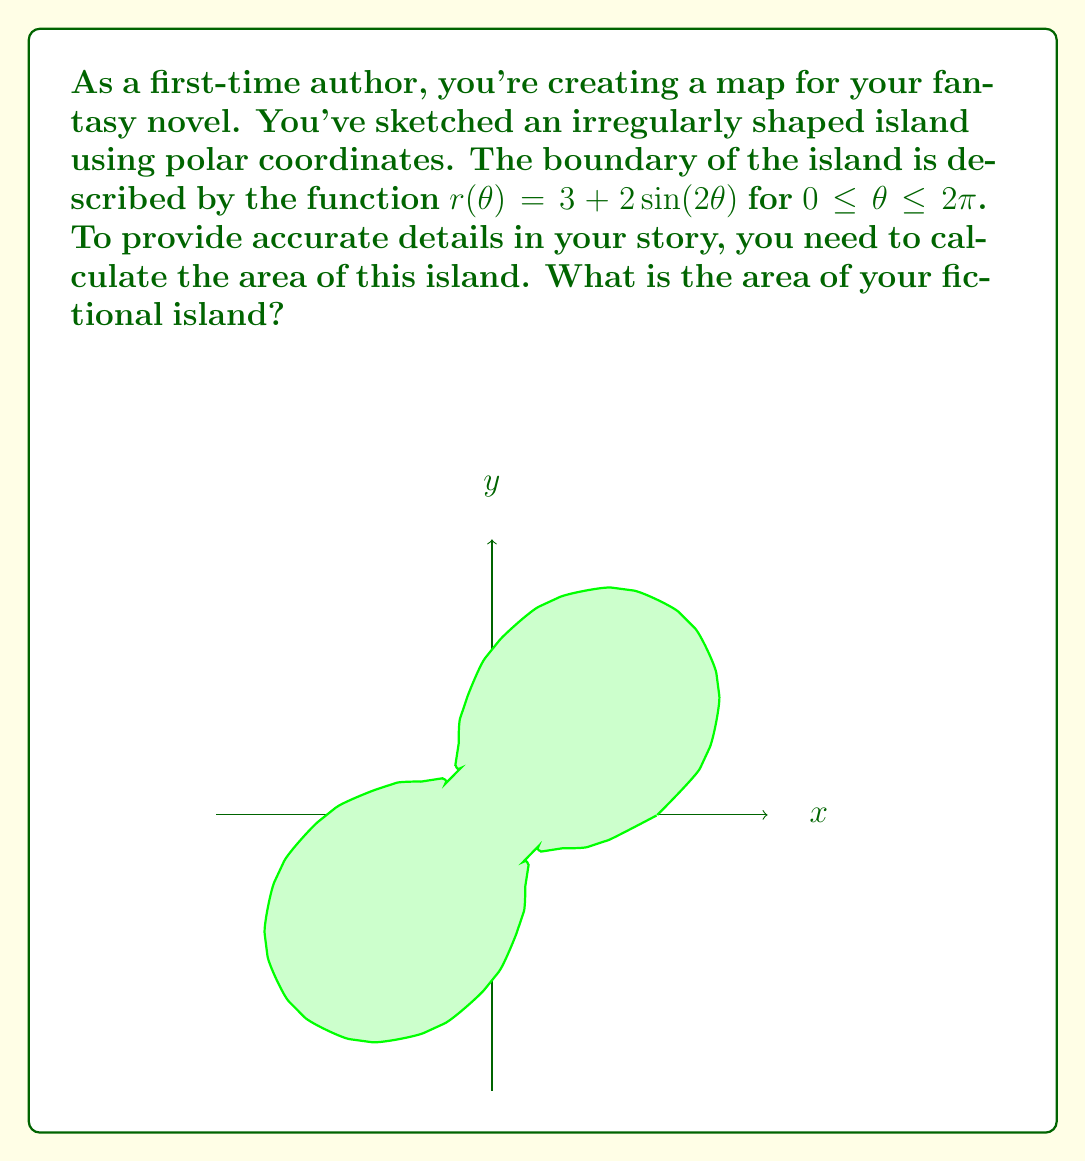Help me with this question. To determine the area of this irregularly shaped island, we'll use polar integration. The formula for the area of a region in polar coordinates is:

$$A = \frac{1}{2} \int_a^b [r(\theta)]^2 d\theta$$

Where $r(\theta)$ is the given function and $a$ and $b$ are the starting and ending angles, respectively.

Step 1: Set up the integral
$$A = \frac{1}{2} \int_0^{2\pi} [3 + 2\sin(2\theta)]^2 d\theta$$

Step 2: Expand the squared term
$$A = \frac{1}{2} \int_0^{2\pi} [9 + 12\sin(2\theta) + 4\sin^2(2\theta)] d\theta$$

Step 3: Integrate each term
- $\int_0^{2\pi} 9 d\theta = 9\theta \big|_0^{2\pi} = 18\pi$
- $\int_0^{2\pi} 12\sin(2\theta) d\theta = -6\cos(2\theta) \big|_0^{2\pi} = 0$
- $\int_0^{2\pi} 4\sin^2(2\theta) d\theta = 2\theta - \sin(4\theta) \big|_0^{2\pi} = 4\pi$

Step 4: Sum up the results and multiply by $\frac{1}{2}$
$$A = \frac{1}{2}(18\pi + 0 + 4\pi) = \frac{1}{2}(22\pi) = 11\pi$$

Therefore, the area of your fictional island is $11\pi$ square units.
Answer: $11\pi$ square units 